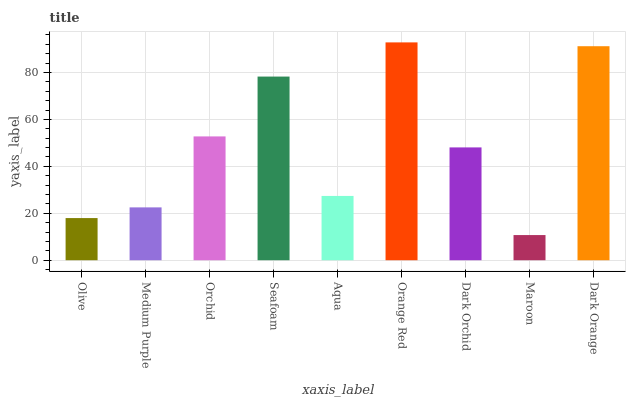Is Maroon the minimum?
Answer yes or no. Yes. Is Orange Red the maximum?
Answer yes or no. Yes. Is Medium Purple the minimum?
Answer yes or no. No. Is Medium Purple the maximum?
Answer yes or no. No. Is Medium Purple greater than Olive?
Answer yes or no. Yes. Is Olive less than Medium Purple?
Answer yes or no. Yes. Is Olive greater than Medium Purple?
Answer yes or no. No. Is Medium Purple less than Olive?
Answer yes or no. No. Is Dark Orchid the high median?
Answer yes or no. Yes. Is Dark Orchid the low median?
Answer yes or no. Yes. Is Dark Orange the high median?
Answer yes or no. No. Is Medium Purple the low median?
Answer yes or no. No. 